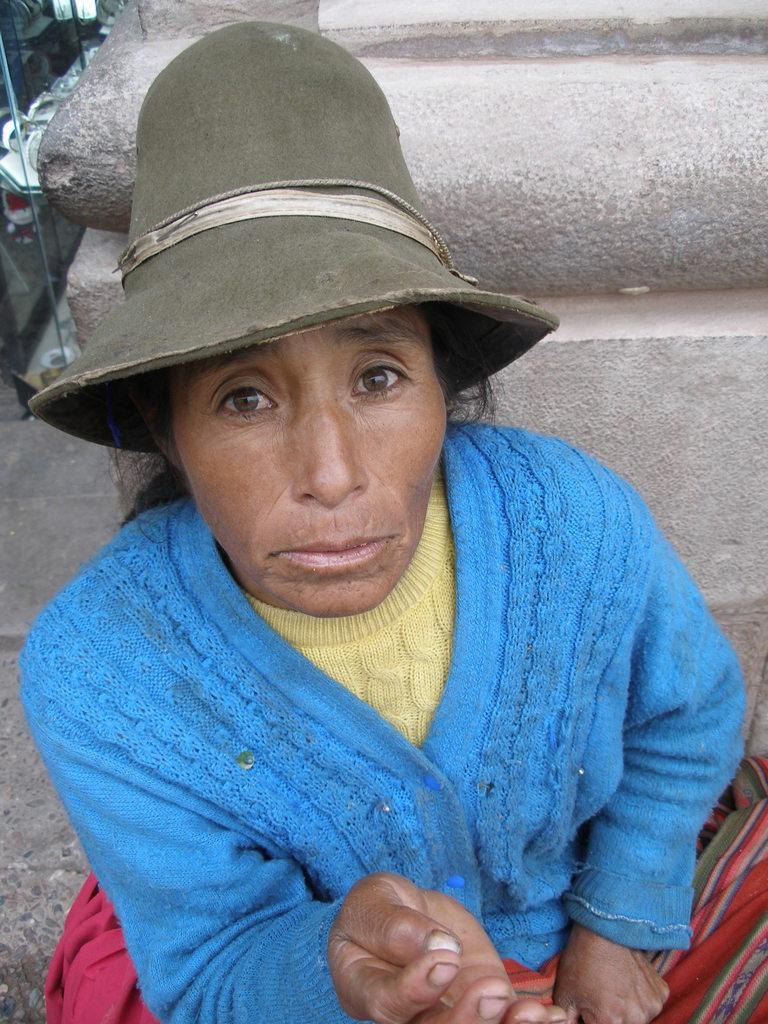Who is the main subject in the image? There is a woman in the image. What is the woman doing in the image? The woman is sitting. What can be seen behind the woman in the image? The woman is in front of a pillar. What type of square object is the woman holding in the image? There is no square object visible in the image. What emotion is the woman expressing in the image? The image does not show the woman's emotions, so it cannot be determined from the image. 